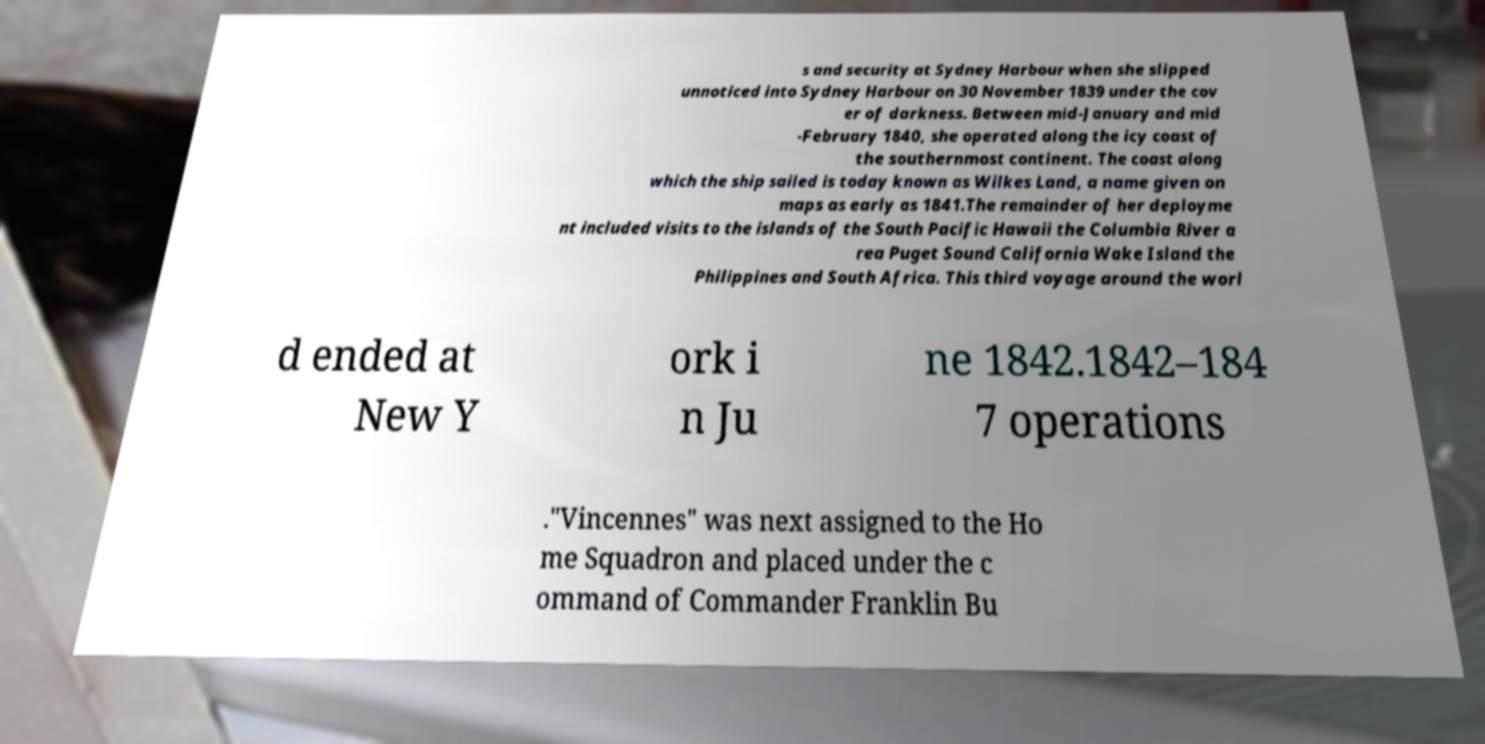There's text embedded in this image that I need extracted. Can you transcribe it verbatim? s and security at Sydney Harbour when she slipped unnoticed into Sydney Harbour on 30 November 1839 under the cov er of darkness. Between mid-January and mid -February 1840, she operated along the icy coast of the southernmost continent. The coast along which the ship sailed is today known as Wilkes Land, a name given on maps as early as 1841.The remainder of her deployme nt included visits to the islands of the South Pacific Hawaii the Columbia River a rea Puget Sound California Wake Island the Philippines and South Africa. This third voyage around the worl d ended at New Y ork i n Ju ne 1842.1842–184 7 operations ."Vincennes" was next assigned to the Ho me Squadron and placed under the c ommand of Commander Franklin Bu 